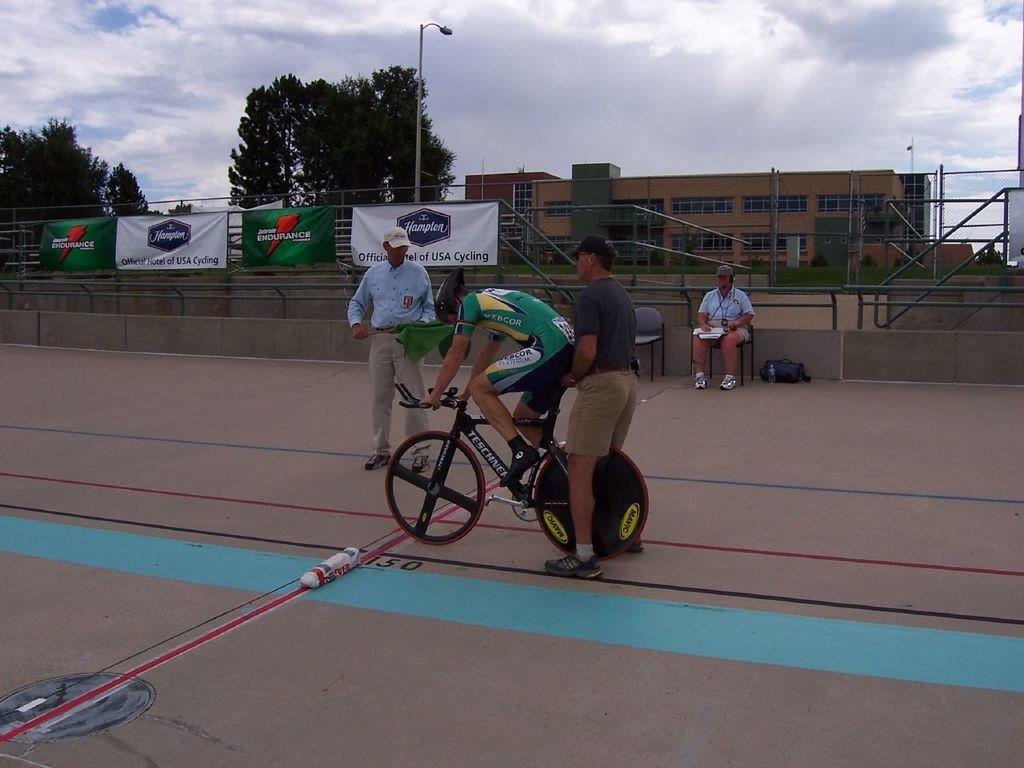Could you give a brief overview of what you see in this image? In this picture I can see a person with a bicycle, there are two persons standing, a person sitting on the chair, there is a bag and a bottle, there are banners, iron rods, poles, lights, trees, there is a building, and in the background there is sky. 